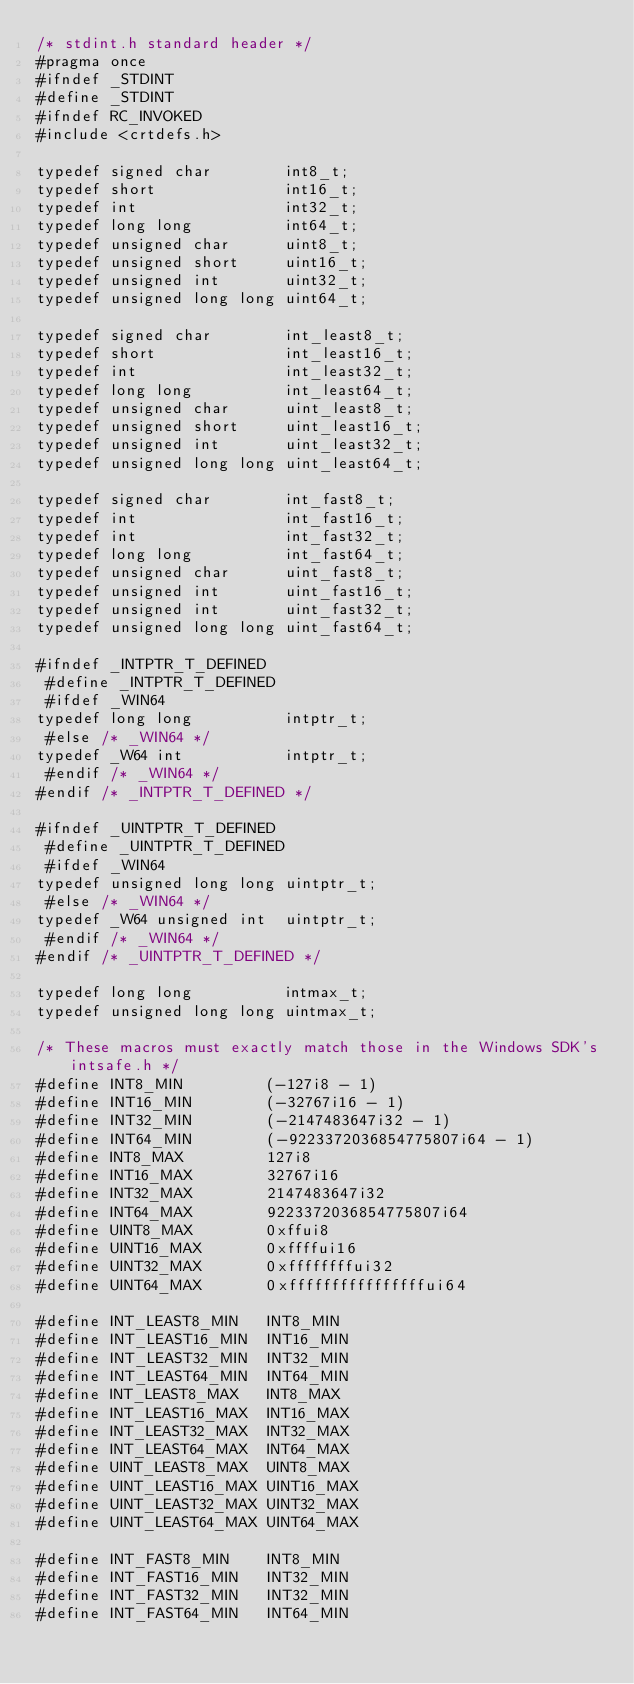<code> <loc_0><loc_0><loc_500><loc_500><_C_>/* stdint.h standard header */
#pragma once
#ifndef _STDINT
#define _STDINT
#ifndef RC_INVOKED
#include <crtdefs.h>

typedef signed char        int8_t;
typedef short              int16_t;
typedef int                int32_t;
typedef long long          int64_t;
typedef unsigned char      uint8_t;
typedef unsigned short     uint16_t;
typedef unsigned int       uint32_t;
typedef unsigned long long uint64_t;

typedef signed char        int_least8_t;
typedef short              int_least16_t;
typedef int                int_least32_t;
typedef long long          int_least64_t;
typedef unsigned char      uint_least8_t;
typedef unsigned short     uint_least16_t;
typedef unsigned int       uint_least32_t;
typedef unsigned long long uint_least64_t;

typedef signed char        int_fast8_t;
typedef int                int_fast16_t;
typedef int                int_fast32_t;
typedef long long          int_fast64_t;
typedef unsigned char      uint_fast8_t;
typedef unsigned int       uint_fast16_t;
typedef unsigned int       uint_fast32_t;
typedef unsigned long long uint_fast64_t;

#ifndef _INTPTR_T_DEFINED
 #define _INTPTR_T_DEFINED
 #ifdef _WIN64
typedef long long          intptr_t;
 #else /* _WIN64 */
typedef _W64 int           intptr_t;
 #endif /* _WIN64 */
#endif /* _INTPTR_T_DEFINED */

#ifndef _UINTPTR_T_DEFINED
 #define _UINTPTR_T_DEFINED
 #ifdef _WIN64
typedef unsigned long long uintptr_t;
 #else /* _WIN64 */
typedef _W64 unsigned int  uintptr_t;
 #endif /* _WIN64 */
#endif /* _UINTPTR_T_DEFINED */

typedef long long          intmax_t;
typedef unsigned long long uintmax_t;

/* These macros must exactly match those in the Windows SDK's intsafe.h */
#define INT8_MIN         (-127i8 - 1)
#define INT16_MIN        (-32767i16 - 1)
#define INT32_MIN        (-2147483647i32 - 1)
#define INT64_MIN        (-9223372036854775807i64 - 1)
#define INT8_MAX         127i8
#define INT16_MAX        32767i16
#define INT32_MAX        2147483647i32
#define INT64_MAX        9223372036854775807i64
#define UINT8_MAX        0xffui8
#define UINT16_MAX       0xffffui16
#define UINT32_MAX       0xffffffffui32
#define UINT64_MAX       0xffffffffffffffffui64

#define INT_LEAST8_MIN   INT8_MIN
#define INT_LEAST16_MIN  INT16_MIN
#define INT_LEAST32_MIN  INT32_MIN
#define INT_LEAST64_MIN  INT64_MIN
#define INT_LEAST8_MAX   INT8_MAX
#define INT_LEAST16_MAX  INT16_MAX
#define INT_LEAST32_MAX  INT32_MAX
#define INT_LEAST64_MAX  INT64_MAX
#define UINT_LEAST8_MAX  UINT8_MAX
#define UINT_LEAST16_MAX UINT16_MAX
#define UINT_LEAST32_MAX UINT32_MAX
#define UINT_LEAST64_MAX UINT64_MAX

#define INT_FAST8_MIN    INT8_MIN
#define INT_FAST16_MIN   INT32_MIN
#define INT_FAST32_MIN   INT32_MIN
#define INT_FAST64_MIN   INT64_MIN</code> 